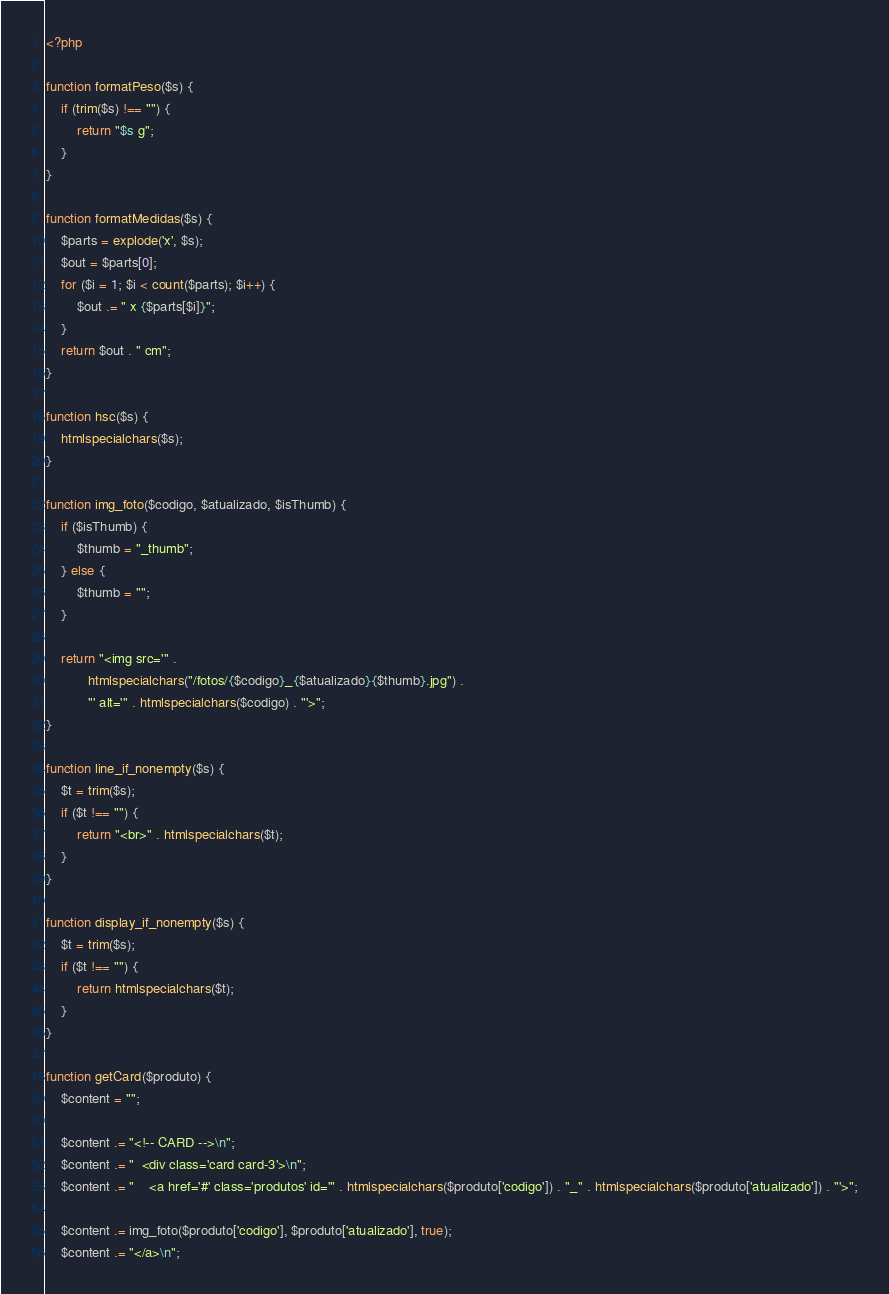Convert code to text. <code><loc_0><loc_0><loc_500><loc_500><_PHP_><?php

function formatPeso($s) {
    if (trim($s) !== "") {
        return "$s g";
    }
}

function formatMedidas($s) {
    $parts = explode('x', $s);
    $out = $parts[0];
    for ($i = 1; $i < count($parts); $i++) {
        $out .= " x {$parts[$i]}";
    }
    return $out . " cm";
}

function hsc($s) {
    htmlspecialchars($s);
}

function img_foto($codigo, $atualizado, $isThumb) {
    if ($isThumb) {
        $thumb = "_thumb";
    } else {
        $thumb = "";
    }
    
    return "<img src='" .
           htmlspecialchars("/fotos/{$codigo}_{$atualizado}{$thumb}.jpg") .
           "' alt='" . htmlspecialchars($codigo) . "'>";           
}

function line_if_nonempty($s) {
    $t = trim($s);
    if ($t !== "") {
        return "<br>" . htmlspecialchars($t);
    }
}

function display_if_nonempty($s) {
    $t = trim($s);
    if ($t !== "") {
        return htmlspecialchars($t);
    }
}

function getCard($produto) {
    $content = "";
    
    $content .= "<!-- CARD -->\n";
    $content .= "  <div class='card card-3'>\n";
    $content .= "    <a href='#' class='produtos' id='" . htmlspecialchars($produto['codigo']) . "_" . htmlspecialchars($produto['atualizado']) . "'>";

    $content .= img_foto($produto['codigo'], $produto['atualizado'], true);
    $content .= "</a>\n";</code> 